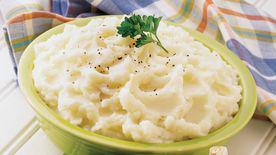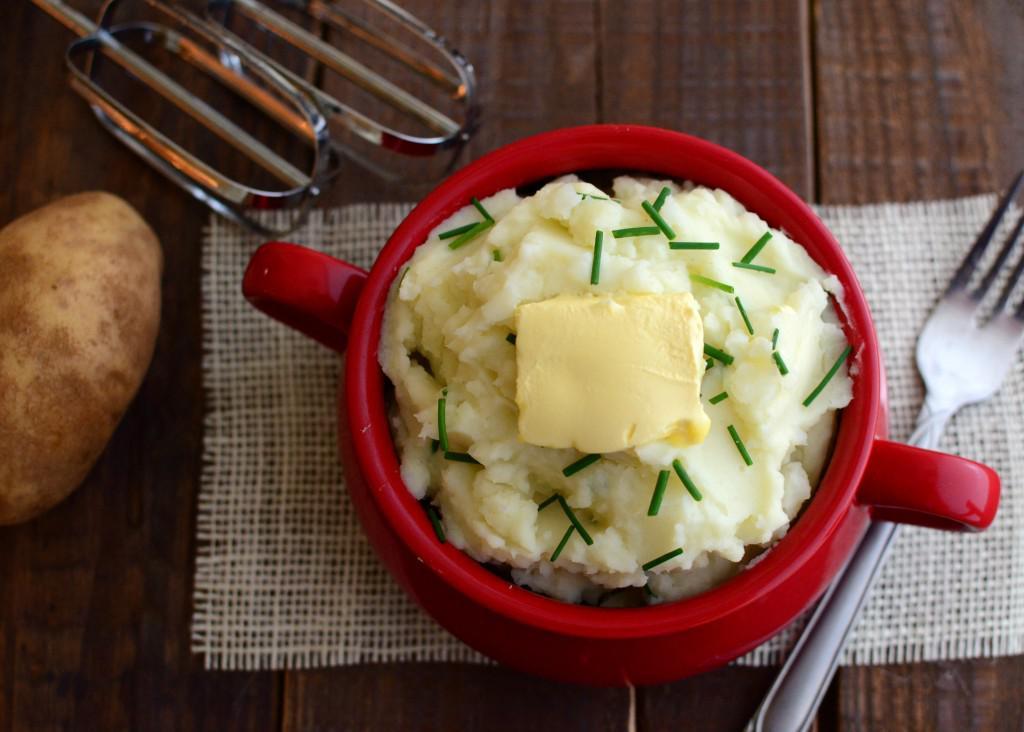The first image is the image on the left, the second image is the image on the right. Given the left and right images, does the statement "In one image, mashed potatoes are served in a red bowl with a pat of butter and chopped chives." hold true? Answer yes or no. Yes. The first image is the image on the left, the second image is the image on the right. For the images shown, is this caption "An image shows a red container with a fork next to it." true? Answer yes or no. Yes. 